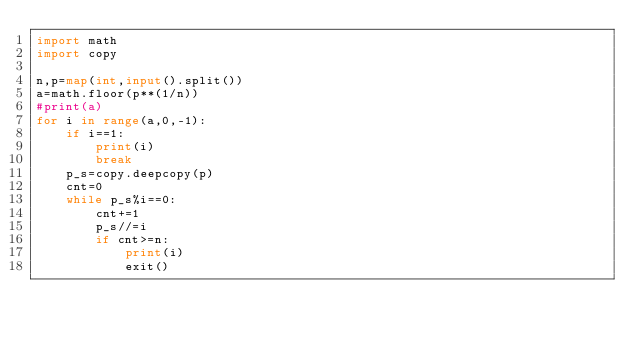Convert code to text. <code><loc_0><loc_0><loc_500><loc_500><_Python_>import math
import copy
 
n,p=map(int,input().split())
a=math.floor(p**(1/n))
#print(a)
for i in range(a,0,-1):
    if i==1:
        print(i)
        break
    p_s=copy.deepcopy(p)
    cnt=0
    while p_s%i==0:
        cnt+=1
        p_s//=i
        if cnt>=n:
            print(i)
            exit()</code> 